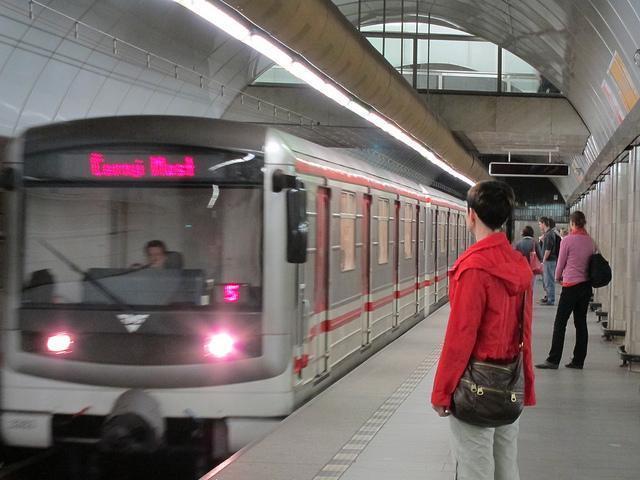How many people are visible?
Give a very brief answer. 2. 